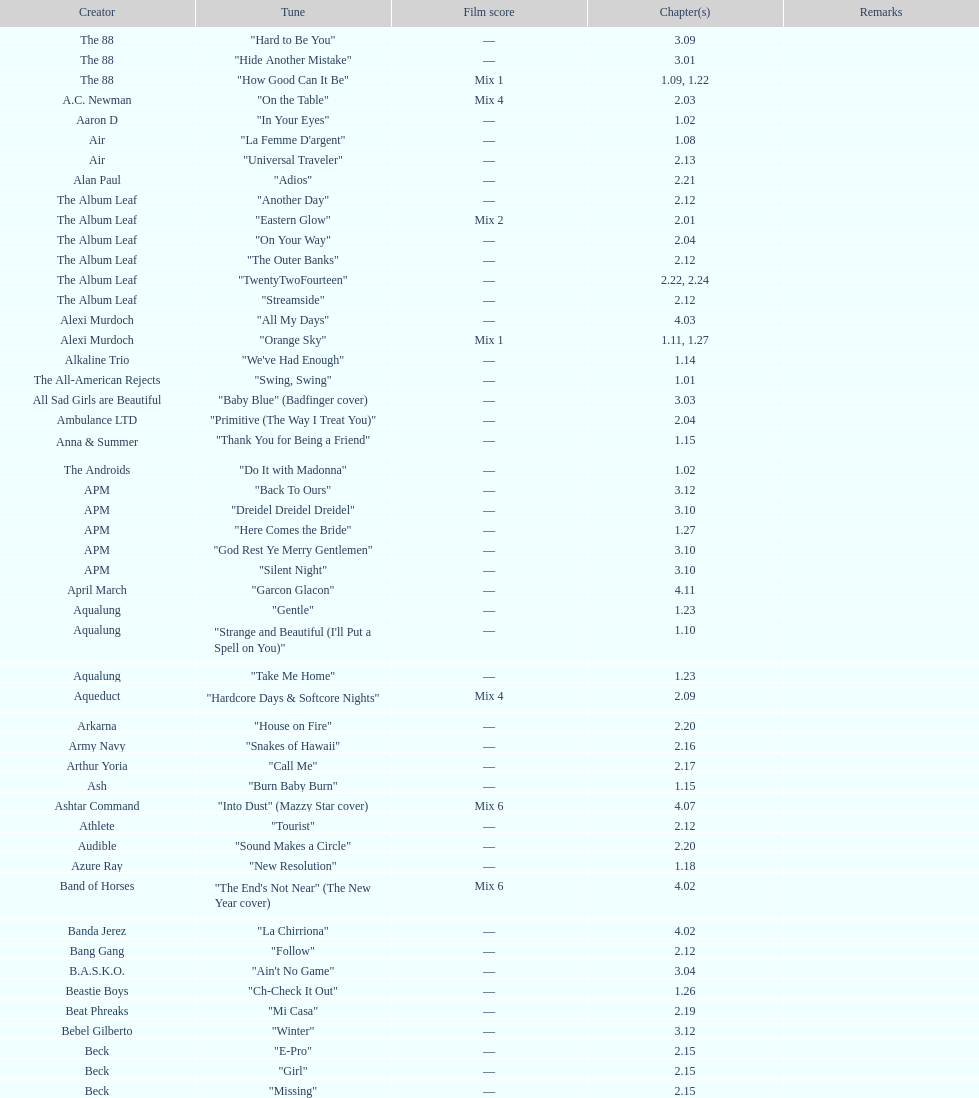"girl" and "el pro" were performed by which artist? Beck. 